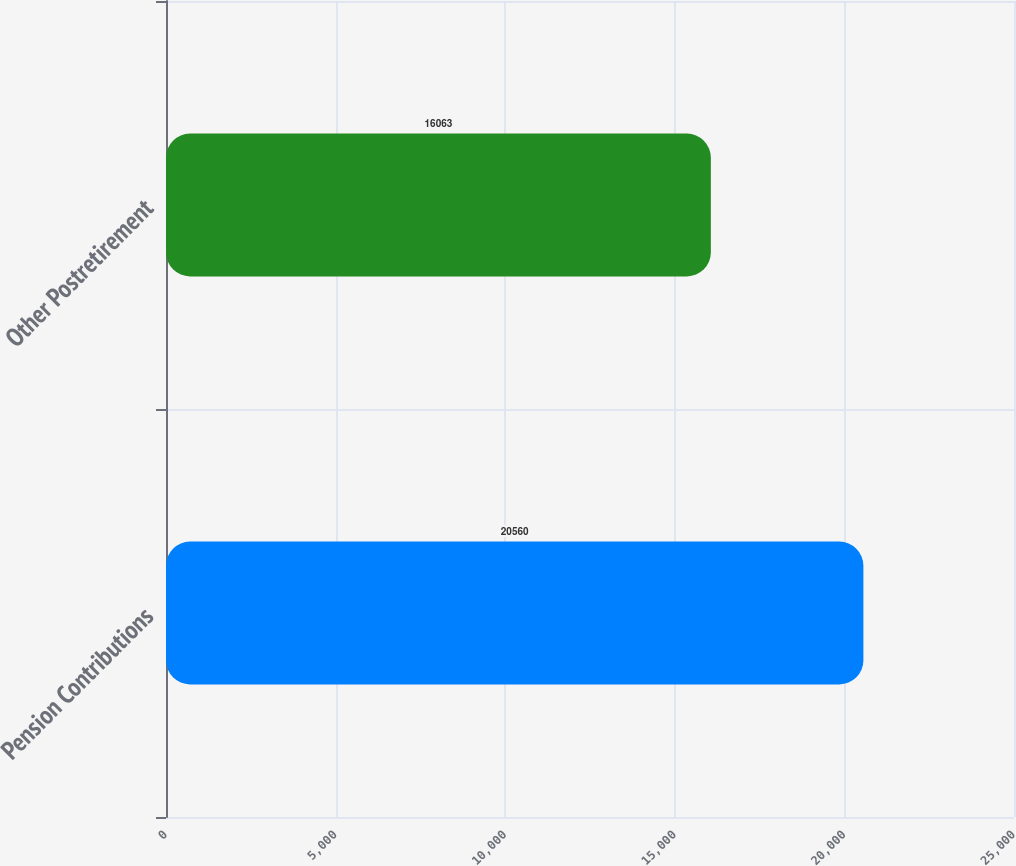Convert chart. <chart><loc_0><loc_0><loc_500><loc_500><bar_chart><fcel>Pension Contributions<fcel>Other Postretirement<nl><fcel>20560<fcel>16063<nl></chart> 